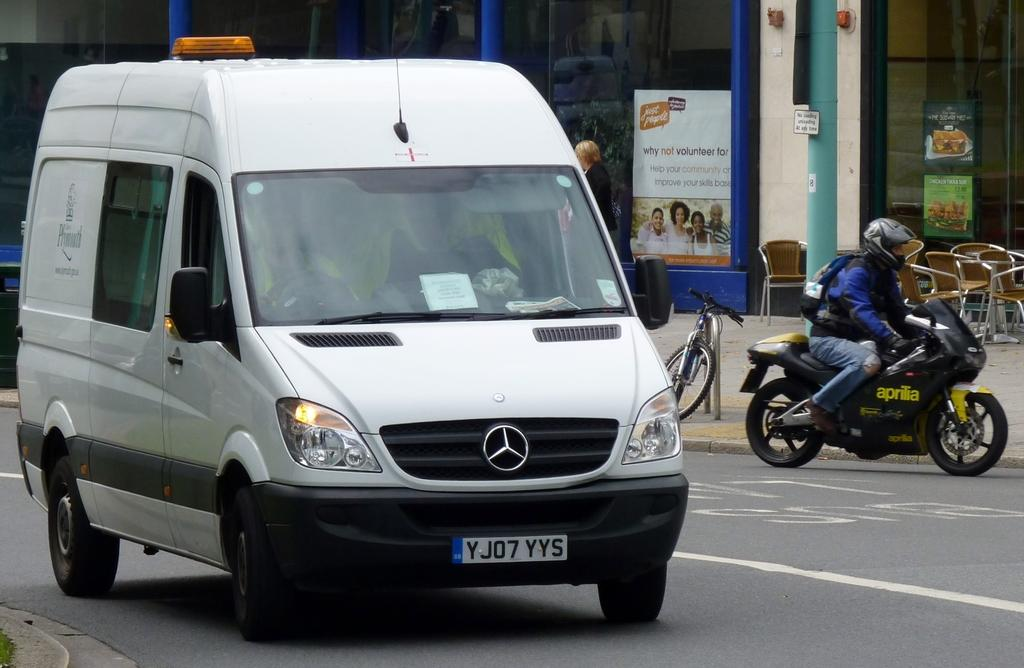<image>
Render a clear and concise summary of the photo. the letter Y starts the license plate of a white van 